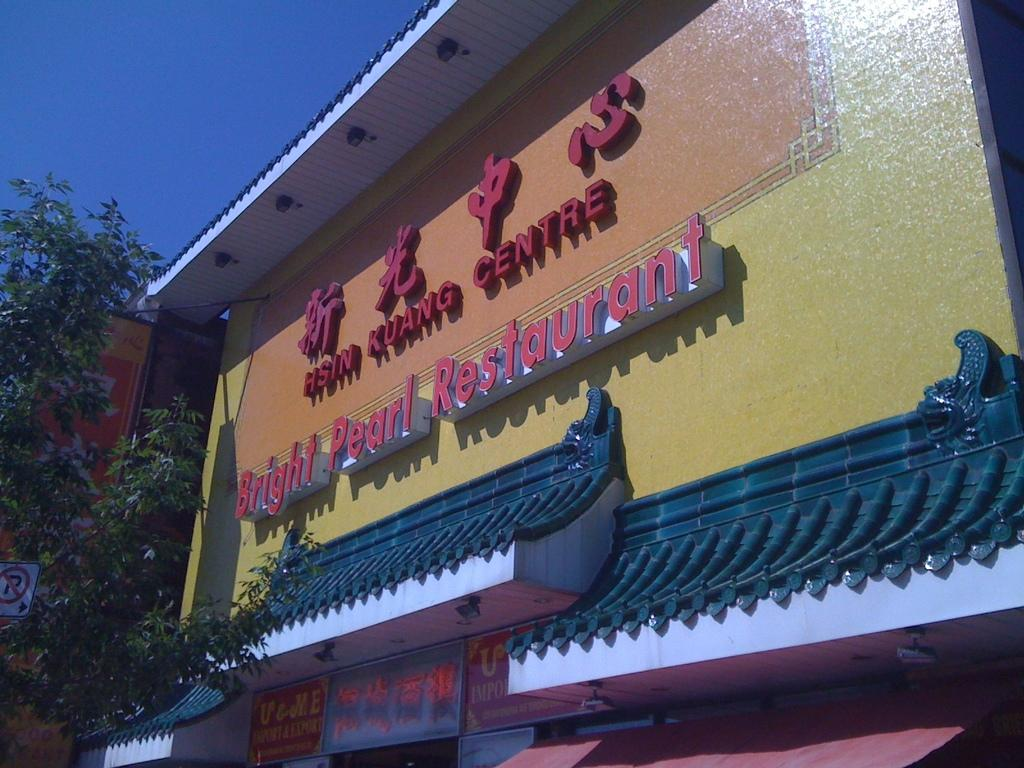<image>
Render a clear and concise summary of the photo. hsin kuang centre bright pearl restaurant building exterior 